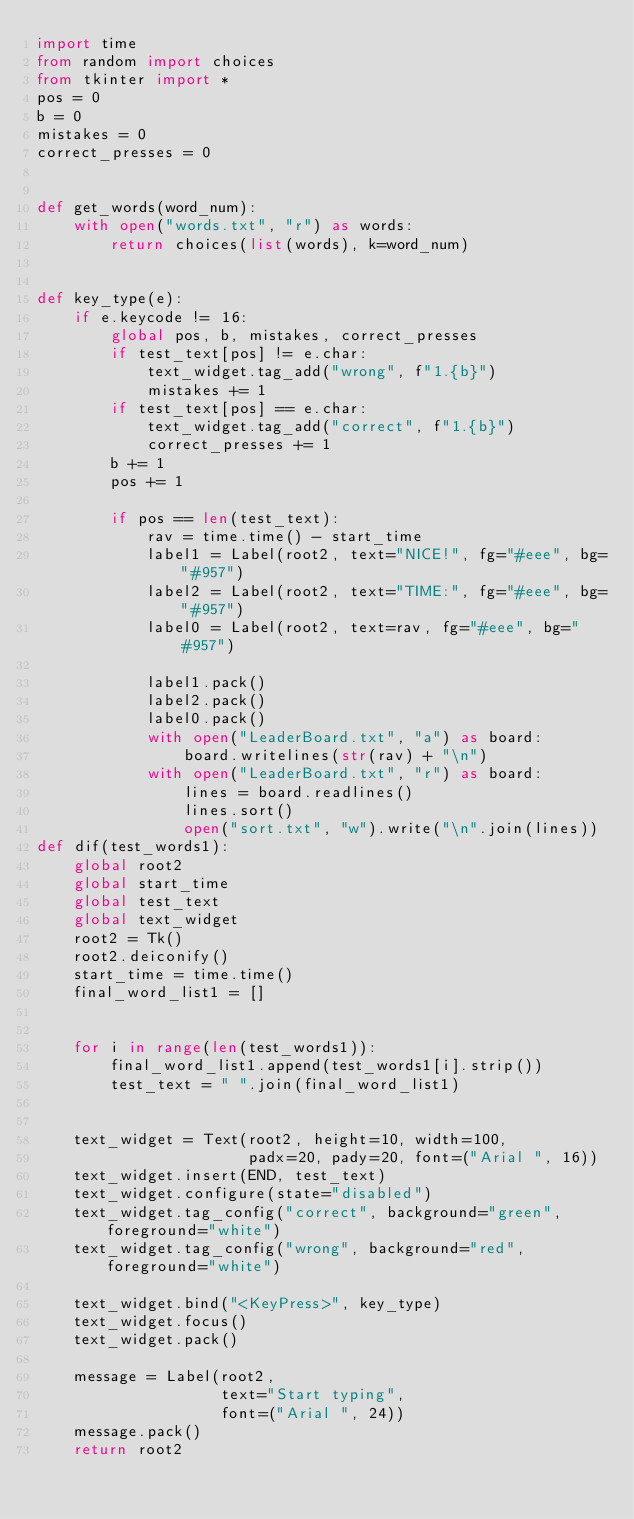<code> <loc_0><loc_0><loc_500><loc_500><_Python_>import time
from random import choices
from tkinter import *
pos = 0
b = 0
mistakes = 0
correct_presses = 0


def get_words(word_num):
    with open("words.txt", "r") as words:
        return choices(list(words), k=word_num)


def key_type(e):
    if e.keycode != 16:
        global pos, b, mistakes, correct_presses
        if test_text[pos] != e.char:
            text_widget.tag_add("wrong", f"1.{b}")
            mistakes += 1
        if test_text[pos] == e.char:
            text_widget.tag_add("correct", f"1.{b}")
            correct_presses += 1
        b += 1
        pos += 1

        if pos == len(test_text):
            rav = time.time() - start_time
            label1 = Label(root2, text="NICE!", fg="#eee", bg="#957")
            label2 = Label(root2, text="TIME:", fg="#eee", bg="#957")
            label0 = Label(root2, text=rav, fg="#eee", bg="#957")

            label1.pack()
            label2.pack()
            label0.pack()
            with open("LeaderBoard.txt", "a") as board:
                board.writelines(str(rav) + "\n")
            with open("LeaderBoard.txt", "r") as board:
                lines = board.readlines()
                lines.sort()
                open("sort.txt", "w").write("\n".join(lines))
def dif(test_words1):
    global root2
    global start_time
    global test_text
    global text_widget
    root2 = Tk()  
    root2.deiconify()  
    start_time = time.time()
    final_word_list1 = []

   
    for i in range(len(test_words1)):
        final_word_list1.append(test_words1[i].strip())
        test_text = " ".join(final_word_list1)
        

    text_widget = Text(root2, height=10, width=100,
                       padx=20, pady=20, font=("Arial ", 16))
    text_widget.insert(END, test_text)
    text_widget.configure(state="disabled")
    text_widget.tag_config("correct", background="green", foreground="white")
    text_widget.tag_config("wrong", background="red", foreground="white")

    text_widget.bind("<KeyPress>", key_type)
    text_widget.focus()
    text_widget.pack()

    message = Label(root2,
                    text="Start typing",
                    font=("Arial ", 24))
    message.pack()
    return root2
</code> 